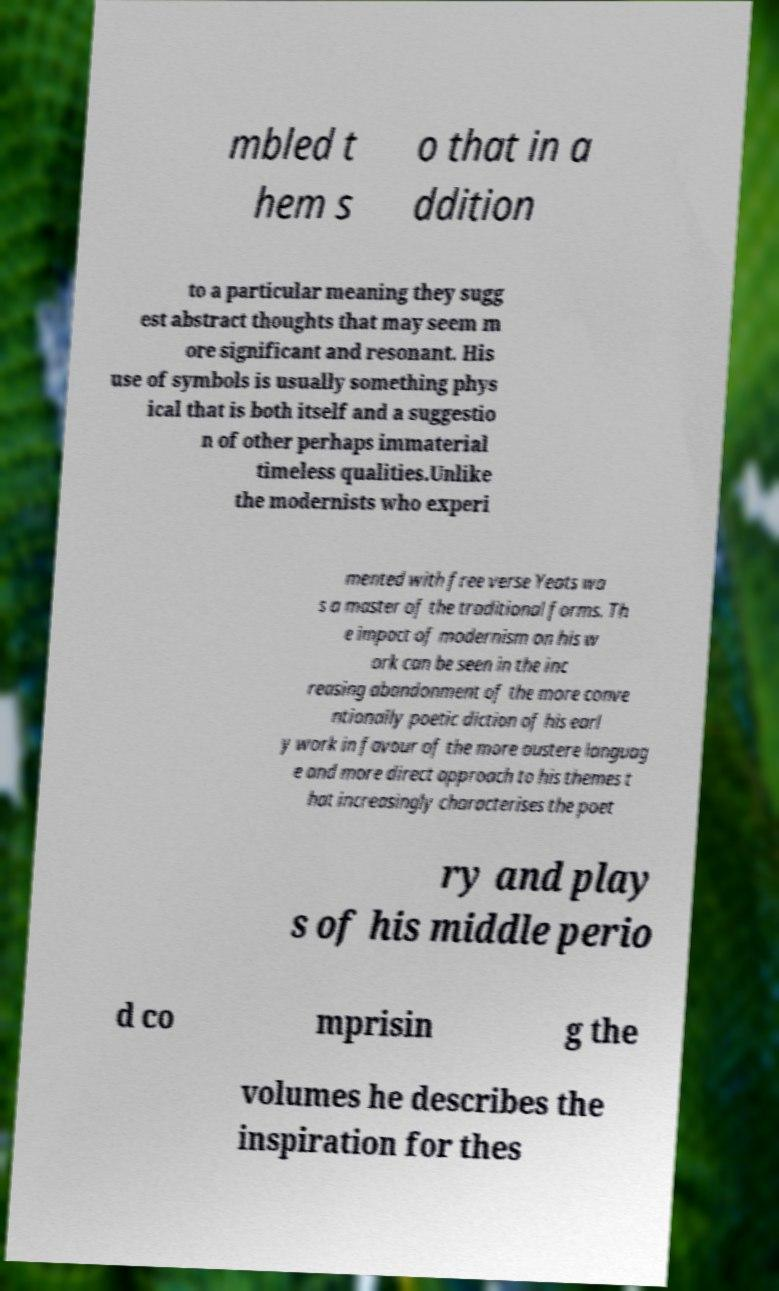I need the written content from this picture converted into text. Can you do that? mbled t hem s o that in a ddition to a particular meaning they sugg est abstract thoughts that may seem m ore significant and resonant. His use of symbols is usually something phys ical that is both itself and a suggestio n of other perhaps immaterial timeless qualities.Unlike the modernists who experi mented with free verse Yeats wa s a master of the traditional forms. Th e impact of modernism on his w ork can be seen in the inc reasing abandonment of the more conve ntionally poetic diction of his earl y work in favour of the more austere languag e and more direct approach to his themes t hat increasingly characterises the poet ry and play s of his middle perio d co mprisin g the volumes he describes the inspiration for thes 